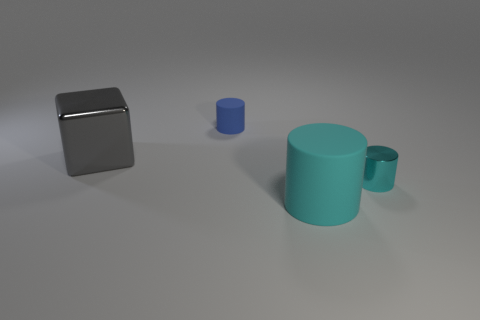There is a small cylinder that is the same material as the big cyan object; what is its color?
Provide a succinct answer. Blue. Does the blue thing have the same shape as the cyan object that is behind the big rubber cylinder?
Give a very brief answer. Yes. There is another big cylinder that is the same color as the shiny cylinder; what material is it?
Your answer should be compact. Rubber. There is a object that is the same size as the cyan rubber cylinder; what is its material?
Provide a succinct answer. Metal. Are there any large objects that have the same color as the small shiny thing?
Make the answer very short. Yes. There is a thing that is in front of the gray shiny cube and to the left of the shiny cylinder; what is its shape?
Your response must be concise. Cylinder. How many small cylinders have the same material as the large cyan cylinder?
Keep it short and to the point. 1. Is the number of large rubber cylinders behind the tiny blue matte thing less than the number of cyan cylinders to the left of the big gray thing?
Keep it short and to the point. No. What is the object left of the tiny thing that is behind the tiny object that is in front of the big gray shiny thing made of?
Your answer should be compact. Metal. There is a thing that is on the right side of the gray metal thing and behind the small cyan cylinder; how big is it?
Provide a succinct answer. Small. 